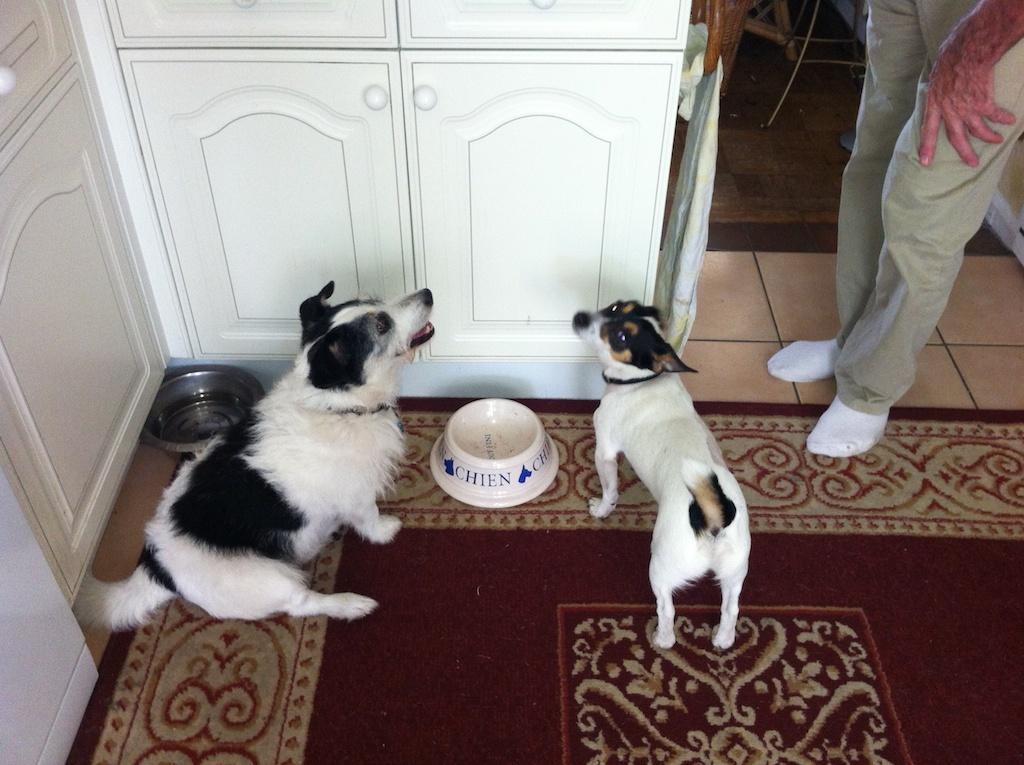Please provide a concise description of this image. In this picture we can see a man and two dogs, in front of the dogs we can find few bowls and cupboards. 